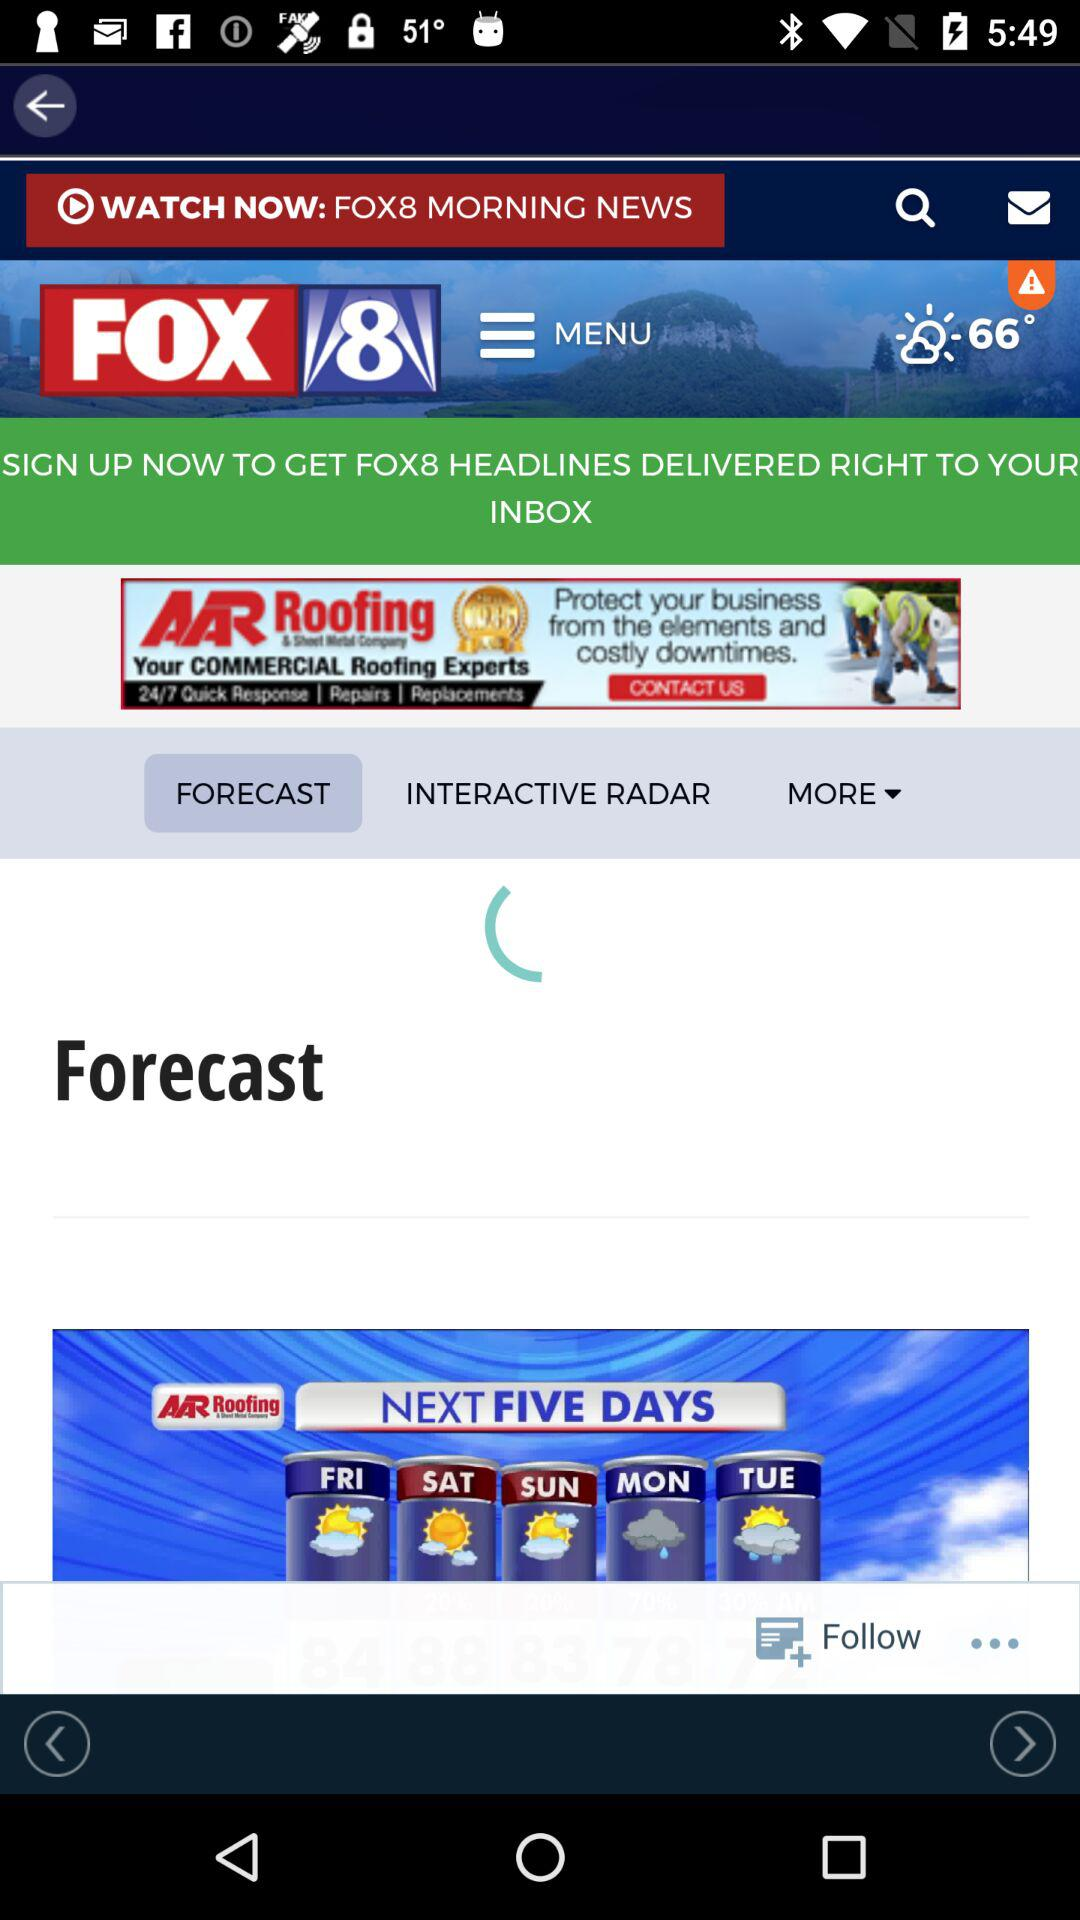What is the name of the application? The application name is "FOX 8". 